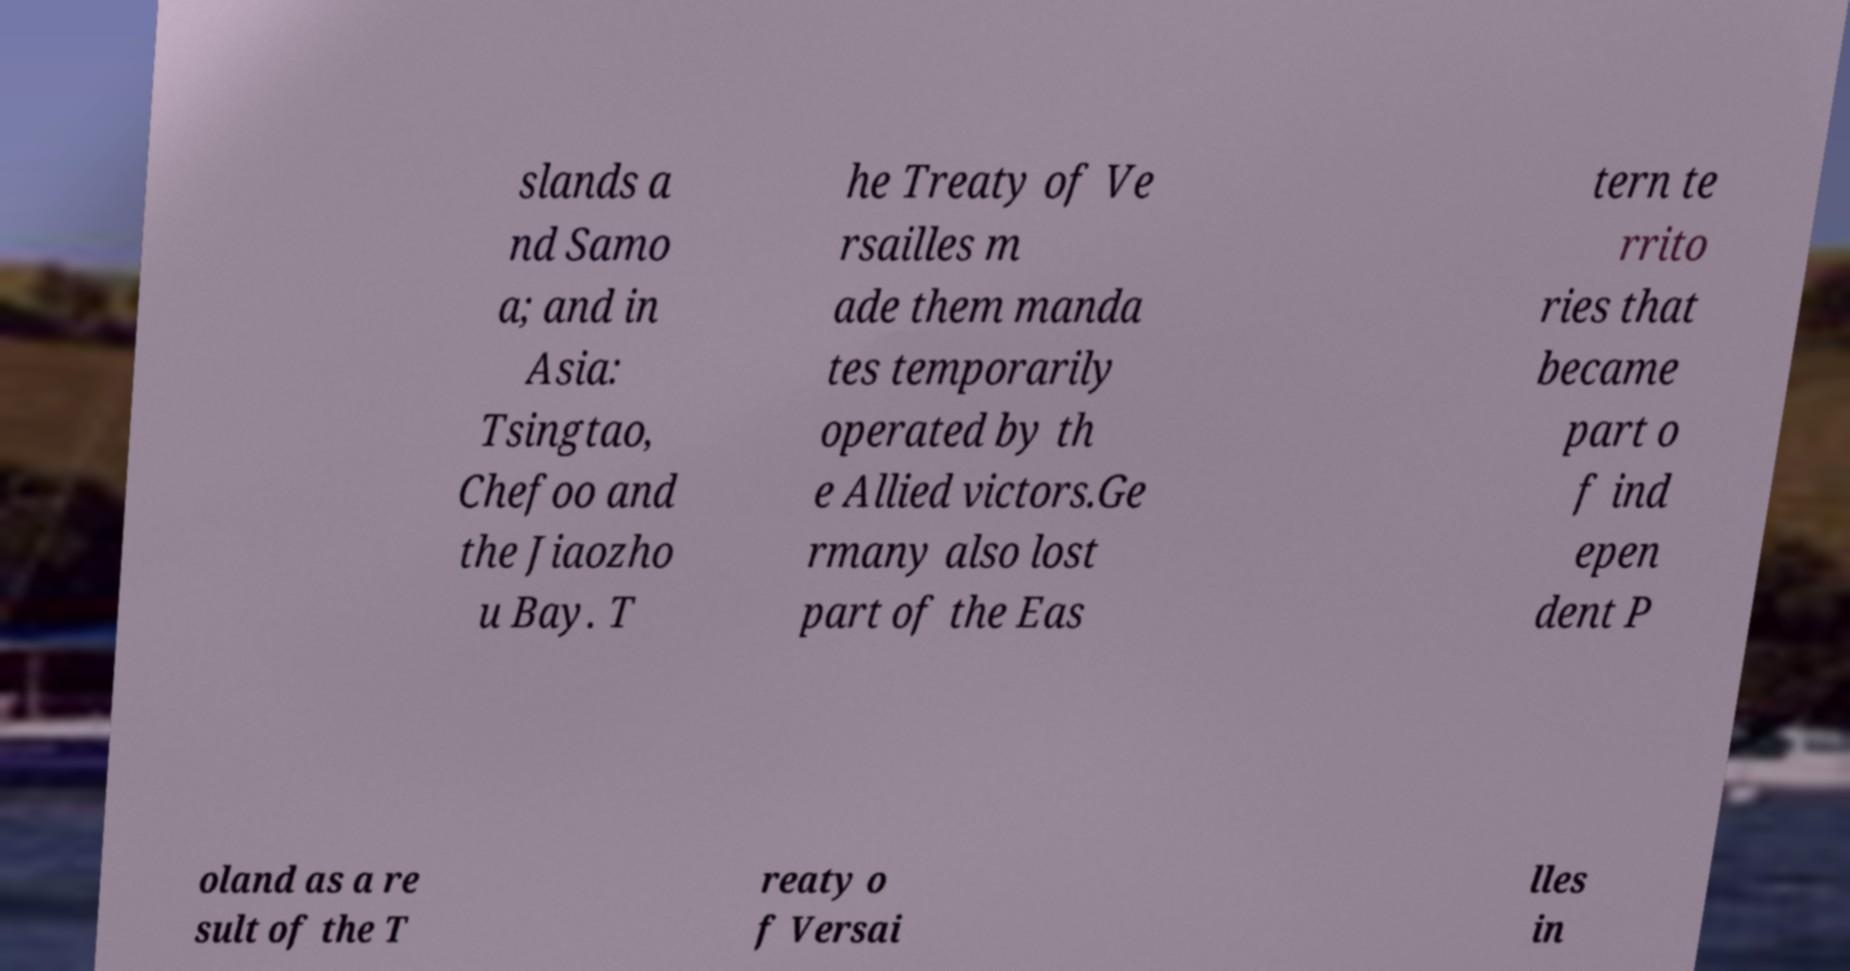Could you extract and type out the text from this image? slands a nd Samo a; and in Asia: Tsingtao, Chefoo and the Jiaozho u Bay. T he Treaty of Ve rsailles m ade them manda tes temporarily operated by th e Allied victors.Ge rmany also lost part of the Eas tern te rrito ries that became part o f ind epen dent P oland as a re sult of the T reaty o f Versai lles in 